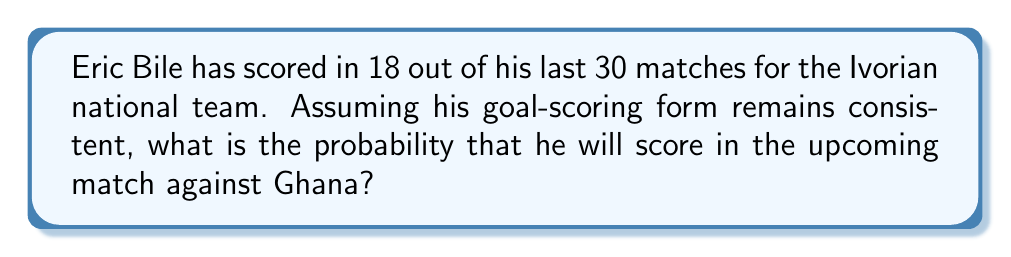Can you answer this question? To solve this problem, we need to use the concept of probability based on past events. We'll treat Eric Bile's goal-scoring as a random variable with a binomial distribution.

Given:
- Eric Bile has scored in 18 out of 30 matches
- We assume his form remains consistent

Step 1: Calculate the probability of Eric Bile scoring in any given match.
$$P(\text{scoring}) = \frac{\text{Number of matches with goals}}{\text{Total number of matches}} = \frac{18}{30} = 0.6$$

Step 2: Interpret the result
This probability of 0.6 or 60% represents the likelihood of Eric Bile scoring in any single match, assuming his form remains consistent.

Step 3: Apply this probability to the upcoming match
Since we're only concerned with a single upcoming match, and we've calculated the probability of scoring in any given match, this probability directly applies to the match against Ghana.

Therefore, the probability of Eric Bile scoring in the upcoming match against Ghana is 0.6 or 60%.
Answer: The probability of Eric Bile scoring in the upcoming match against Ghana is $0.6$ or $60\%$. 